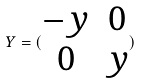Convert formula to latex. <formula><loc_0><loc_0><loc_500><loc_500>Y = ( \begin{matrix} - y & 0 \\ 0 & y \end{matrix} )</formula> 